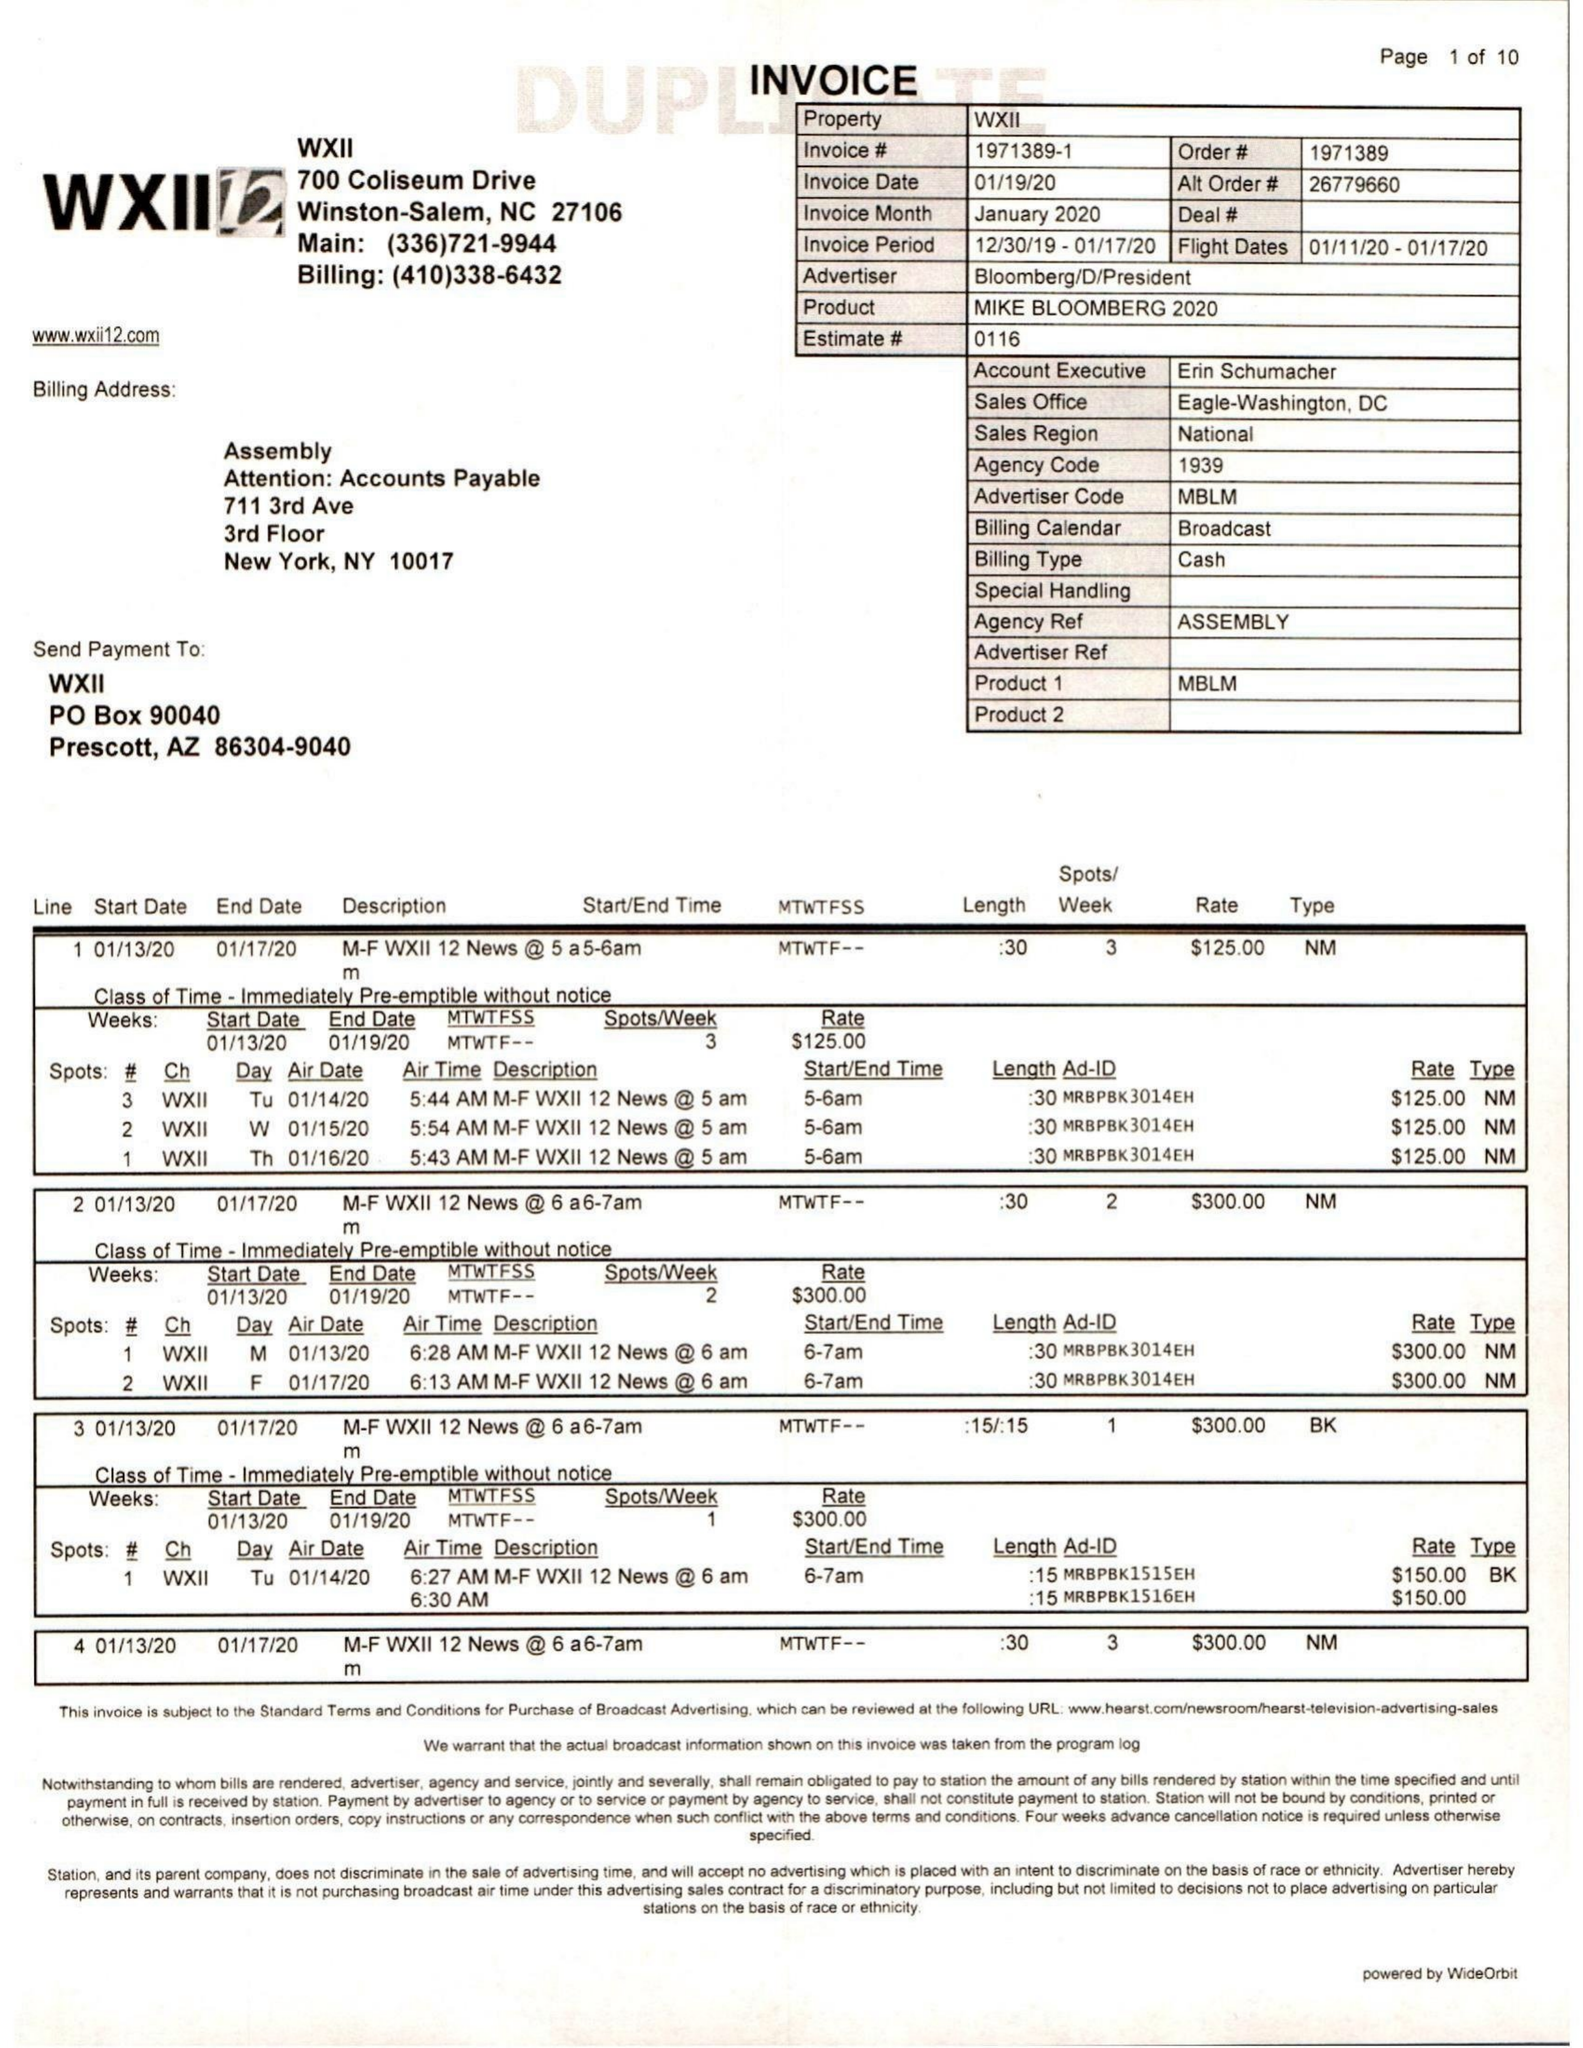What is the value for the gross_amount?
Answer the question using a single word or phrase. 26716.00 